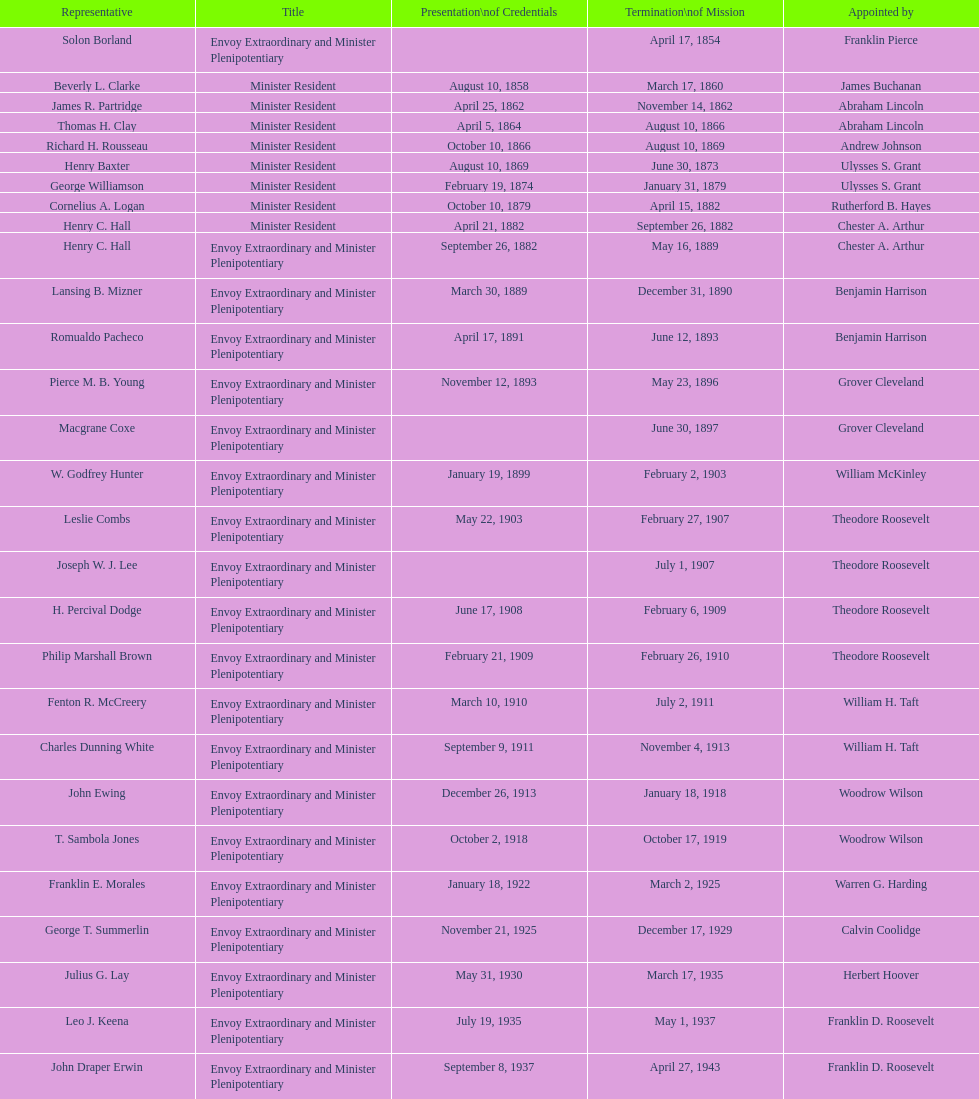Who was the last representative picked? Lisa Kubiske. 